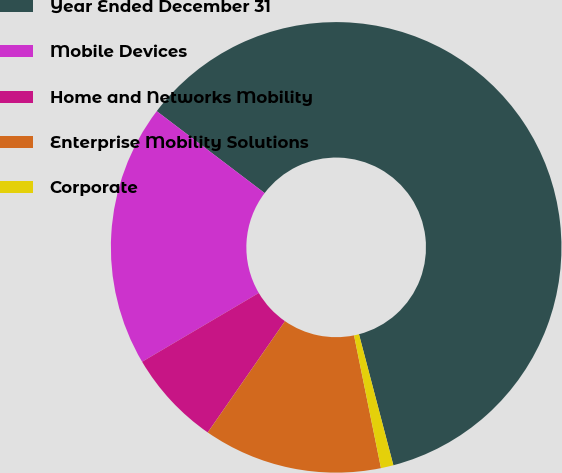Convert chart to OTSL. <chart><loc_0><loc_0><loc_500><loc_500><pie_chart><fcel>Year Ended December 31<fcel>Mobile Devices<fcel>Home and Networks Mobility<fcel>Enterprise Mobility Solutions<fcel>Corporate<nl><fcel>60.58%<fcel>18.81%<fcel>6.87%<fcel>12.84%<fcel>0.9%<nl></chart> 